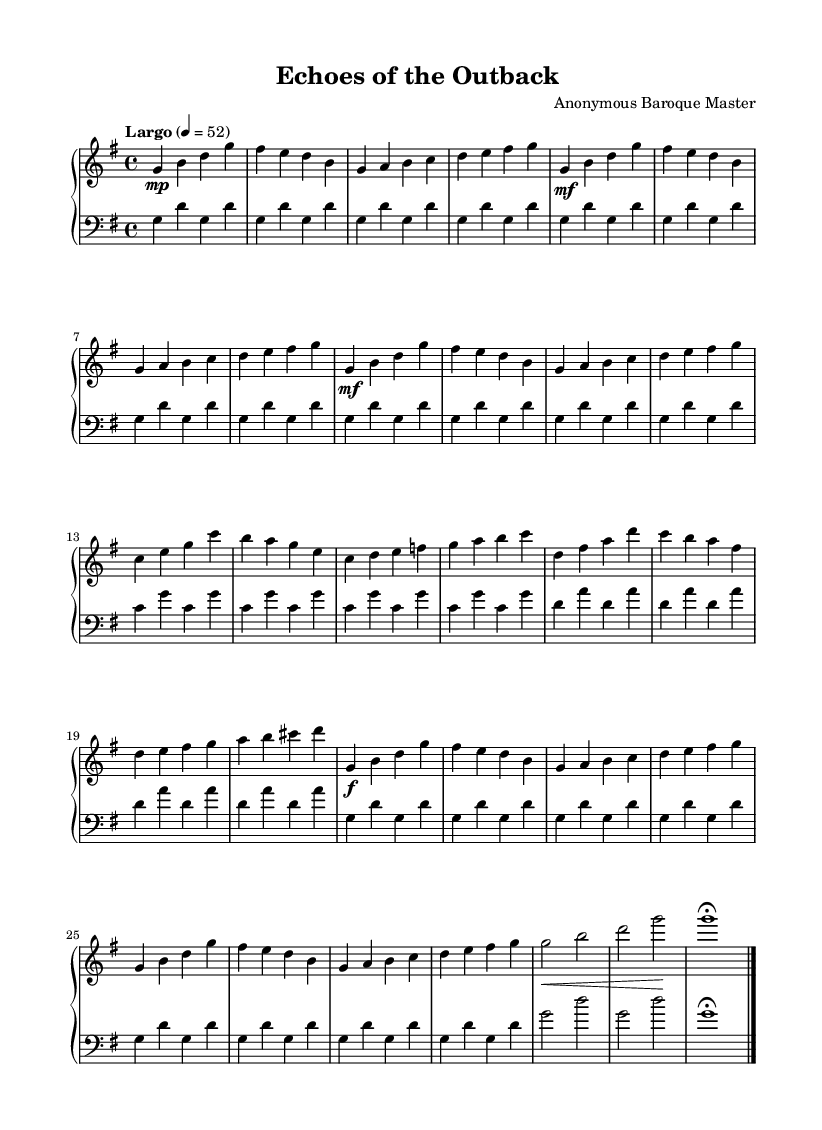What is the key signature of this music? The key signature is indicated by the `g` in the global context, which shows that there is one sharp (F#). This tells us that the key is G major.
Answer: G major What is the time signature of this music? The time signature is specified by the `\time` directive in the global context, which is indicated as 4/4. This means there are four beats in a measure, and each beat is a quarter note.
Answer: 4/4 What is the tempo marking of this music? The tempo is shown in the global context with the text "Largo" followed by a metronome marking of 4 = 52. This means the piece should be played slowly and at a steady pace of 52 beats per minute.
Answer: Largo, 52 How many themes are present in this composition? The composition includes two distinct themes labeled "Theme A" and "Theme B" in the structure, which can be counted based on their specific segments laid out in the sheet.
Answer: 2 What is the dynamic marking at the beginning of Theme A? The dynamic marking at the beginning of Theme A is `mf`, which stands for mezzo-forte, indicating that this section should be played moderately loud.
Answer: mezzo-forte What does the use of `\fermata` indicate at the end of the composition? The `\fermata` symbol indicates that the note should be held longer than its usual duration. The presence of this marking at the end signifies a pause to emphasize the conclusion of the piece.
Answer: Hold What mood might "Echoes of the Outback" evoke through its structure? Given the titles of the themes and the use of the slow tempo, the combination of the G major key with the lyrical melodies typically associated with Baroque organ compositions can suggest a serene, majestic, or expansive feeling, akin to the landscapes of the Australian outback.
Answer: Majestic 